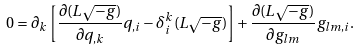Convert formula to latex. <formula><loc_0><loc_0><loc_500><loc_500>0 = \partial _ { k } \left [ \frac { \partial ( L \sqrt { - g } ) } { \partial q _ { , k } } q _ { , i } - \delta ^ { k } _ { i } ( L \sqrt { - g } ) \right ] + \frac { \partial ( L \sqrt { - g } ) } { \partial g _ { l m } } g _ { l m , i } .</formula> 